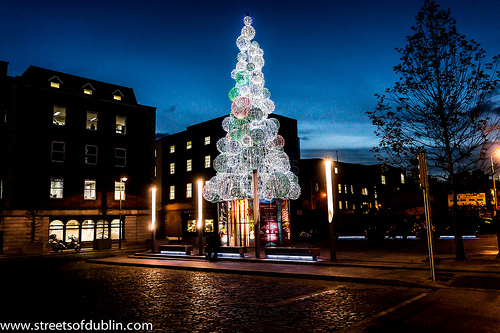<image>
Is the tree behind the building? No. The tree is not behind the building. From this viewpoint, the tree appears to be positioned elsewhere in the scene. 